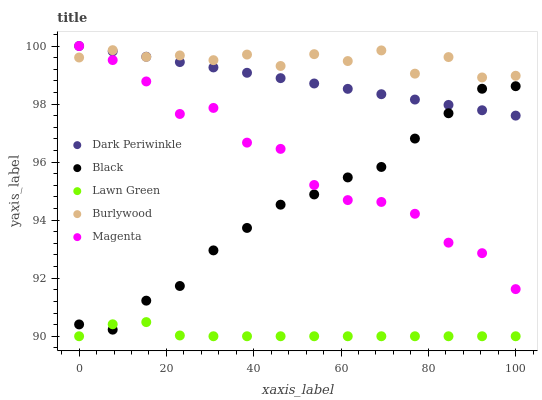Does Lawn Green have the minimum area under the curve?
Answer yes or no. Yes. Does Burlywood have the maximum area under the curve?
Answer yes or no. Yes. Does Magenta have the minimum area under the curve?
Answer yes or no. No. Does Magenta have the maximum area under the curve?
Answer yes or no. No. Is Dark Periwinkle the smoothest?
Answer yes or no. Yes. Is Magenta the roughest?
Answer yes or no. Yes. Is Lawn Green the smoothest?
Answer yes or no. No. Is Lawn Green the roughest?
Answer yes or no. No. Does Lawn Green have the lowest value?
Answer yes or no. Yes. Does Magenta have the lowest value?
Answer yes or no. No. Does Dark Periwinkle have the highest value?
Answer yes or no. Yes. Does Lawn Green have the highest value?
Answer yes or no. No. Is Black less than Burlywood?
Answer yes or no. Yes. Is Dark Periwinkle greater than Lawn Green?
Answer yes or no. Yes. Does Dark Periwinkle intersect Burlywood?
Answer yes or no. Yes. Is Dark Periwinkle less than Burlywood?
Answer yes or no. No. Is Dark Periwinkle greater than Burlywood?
Answer yes or no. No. Does Black intersect Burlywood?
Answer yes or no. No. 